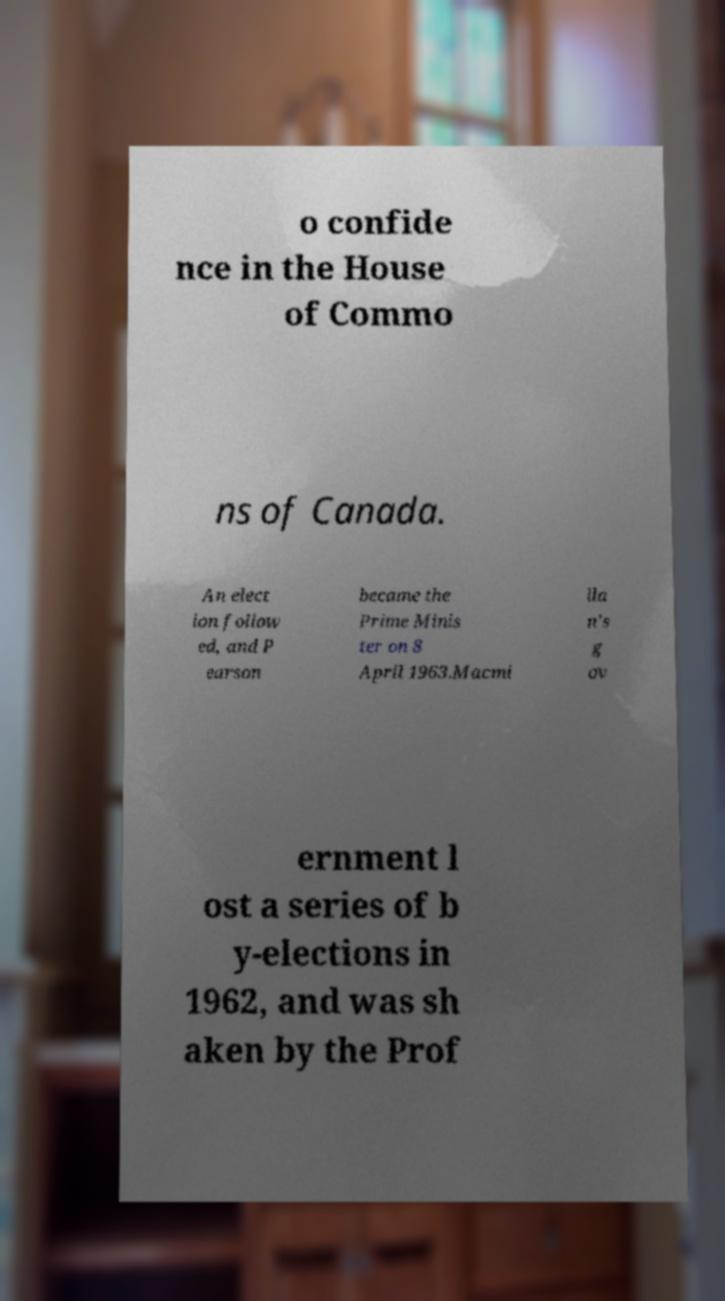Could you assist in decoding the text presented in this image and type it out clearly? o confide nce in the House of Commo ns of Canada. An elect ion follow ed, and P earson became the Prime Minis ter on 8 April 1963.Macmi lla n's g ov ernment l ost a series of b y-elections in 1962, and was sh aken by the Prof 